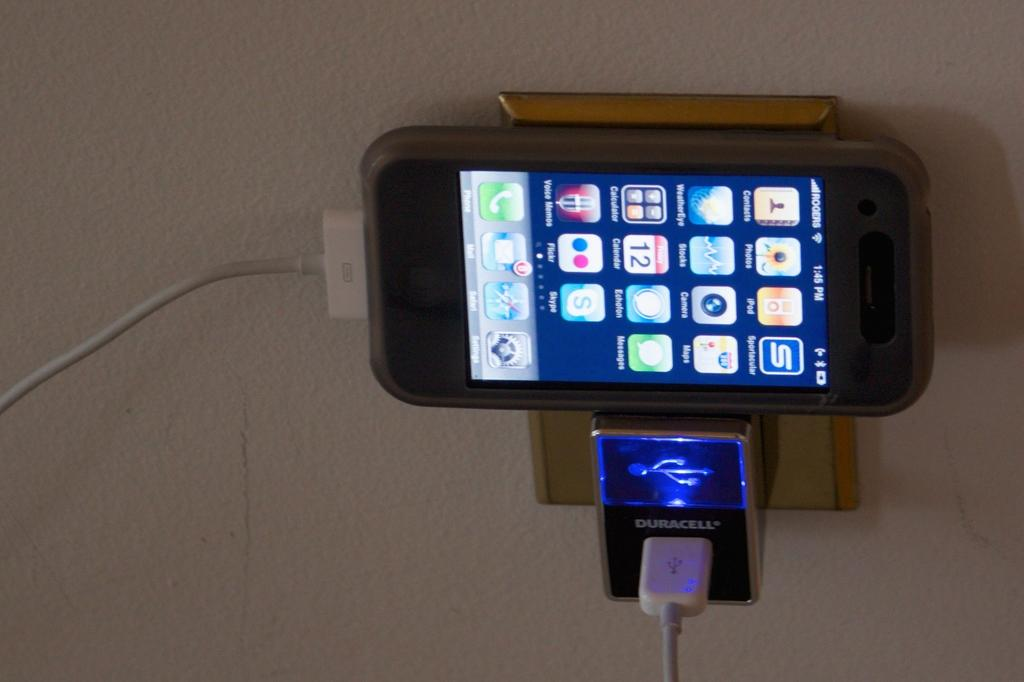<image>
Share a concise interpretation of the image provided. A cell phone rests sideways on top of a plugged in Duracell power pack. 